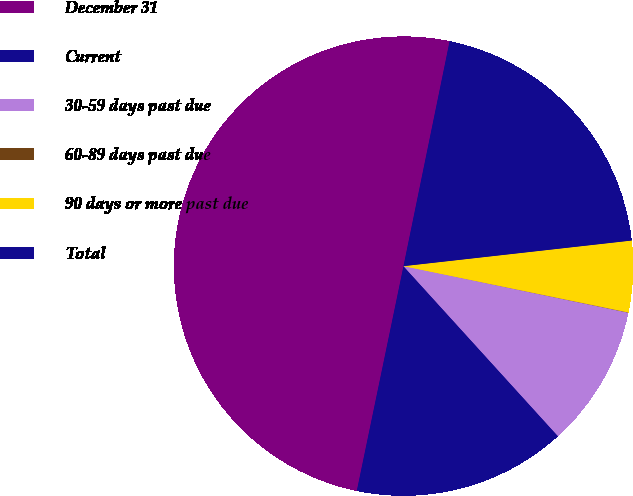<chart> <loc_0><loc_0><loc_500><loc_500><pie_chart><fcel>December 31<fcel>Current<fcel>30-59 days past due<fcel>60-89 days past due<fcel>90 days or more past due<fcel>Total<nl><fcel>49.96%<fcel>15.0%<fcel>10.01%<fcel>0.02%<fcel>5.01%<fcel>20.0%<nl></chart> 